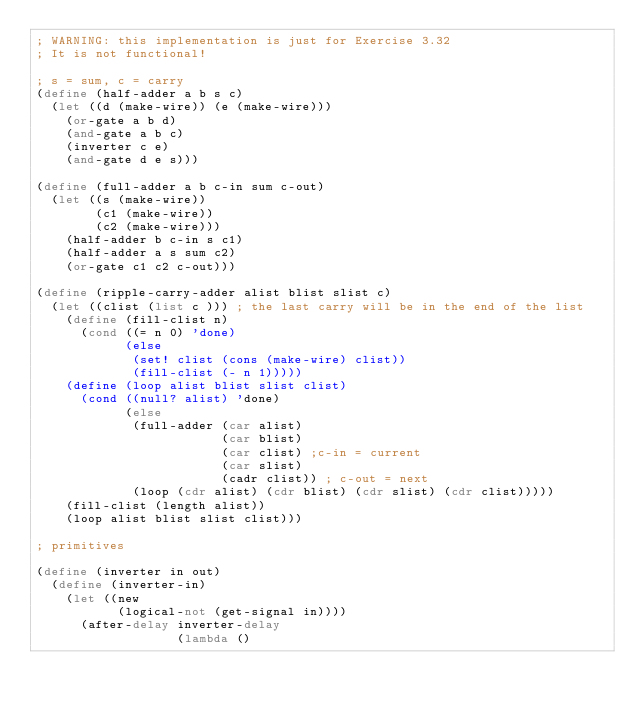<code> <loc_0><loc_0><loc_500><loc_500><_Scheme_>; WARNING: this implementation is just for Exercise 3.32
; It is not functional!

; s = sum, c = carry
(define (half-adder a b s c)
  (let ((d (make-wire)) (e (make-wire)))
    (or-gate a b d)
    (and-gate a b c)
    (inverter c e)
    (and-gate d e s)))
    
(define (full-adder a b c-in sum c-out)
  (let ((s (make-wire))
        (c1 (make-wire))
        (c2 (make-wire)))
    (half-adder b c-in s c1)
    (half-adder a s sum c2)
    (or-gate c1 c2 c-out)))

(define (ripple-carry-adder alist blist slist c)
  (let ((clist (list c ))) ; the last carry will be in the end of the list
    (define (fill-clist n)
      (cond ((= n 0) 'done)
            (else
             (set! clist (cons (make-wire) clist))
             (fill-clist (- n 1)))))                  
    (define (loop alist blist slist clist)
      (cond ((null? alist) 'done)
            (else
             (full-adder (car alist)
                         (car blist)
                         (car clist) ;c-in = current
                         (car slist)
                         (cadr clist)) ; c-out = next
             (loop (cdr alist) (cdr blist) (cdr slist) (cdr clist)))))
    (fill-clist (length alist))
    (loop alist blist slist clist)))

; primitives

(define (inverter in out)
  (define (inverter-in)
    (let ((new
           (logical-not (get-signal in))))
      (after-delay inverter-delay
                   (lambda ()</code> 